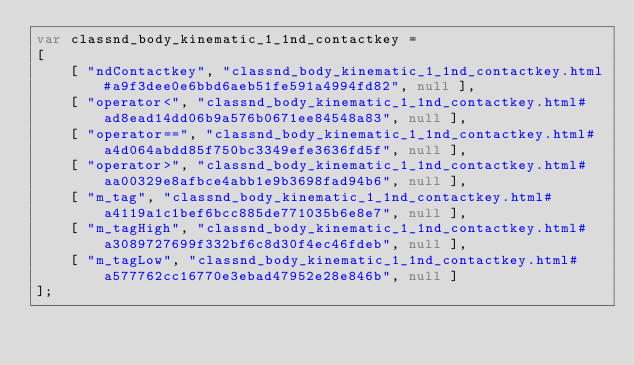<code> <loc_0><loc_0><loc_500><loc_500><_JavaScript_>var classnd_body_kinematic_1_1nd_contactkey =
[
    [ "ndContactkey", "classnd_body_kinematic_1_1nd_contactkey.html#a9f3dee0e6bbd6aeb51fe591a4994fd82", null ],
    [ "operator<", "classnd_body_kinematic_1_1nd_contactkey.html#ad8ead14dd06b9a576b0671ee84548a83", null ],
    [ "operator==", "classnd_body_kinematic_1_1nd_contactkey.html#a4d064abdd85f750bc3349efe3636fd5f", null ],
    [ "operator>", "classnd_body_kinematic_1_1nd_contactkey.html#aa00329e8afbce4abb1e9b3698fad94b6", null ],
    [ "m_tag", "classnd_body_kinematic_1_1nd_contactkey.html#a4119a1c1bef6bcc885de771035b6e8e7", null ],
    [ "m_tagHigh", "classnd_body_kinematic_1_1nd_contactkey.html#a3089727699f332bf6c8d30f4ec46fdeb", null ],
    [ "m_tagLow", "classnd_body_kinematic_1_1nd_contactkey.html#a577762cc16770e3ebad47952e28e846b", null ]
];</code> 